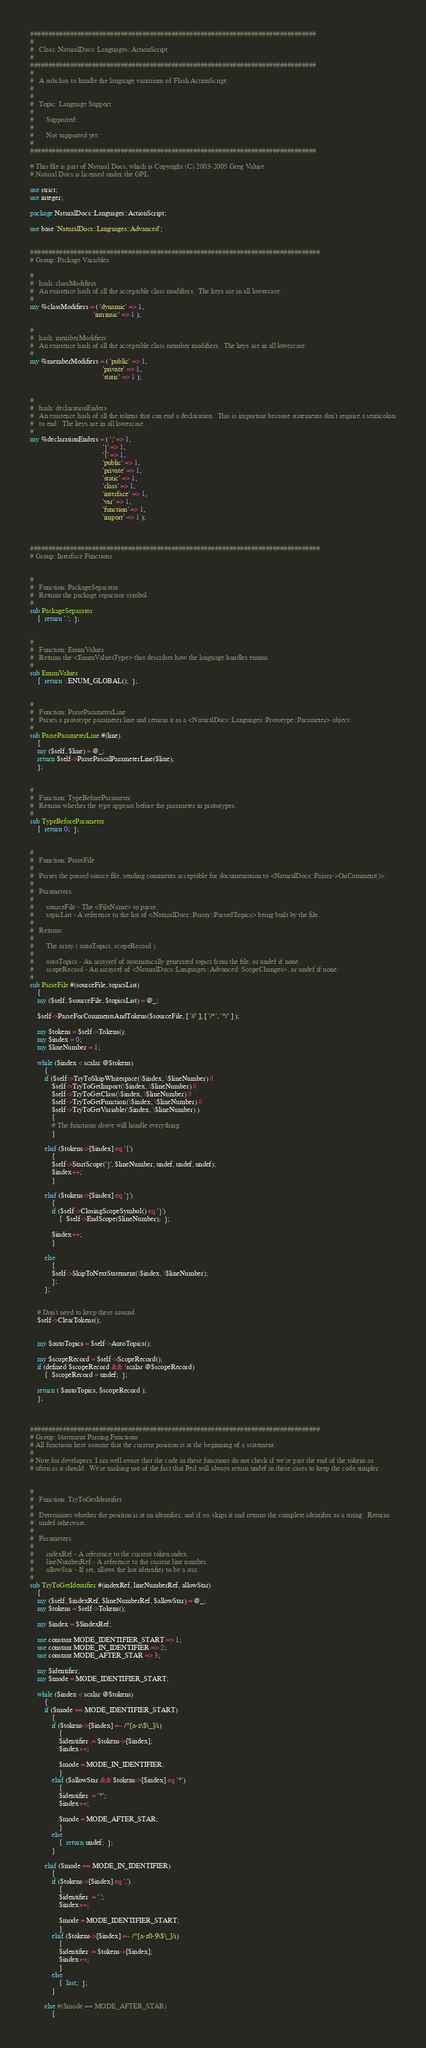<code> <loc_0><loc_0><loc_500><loc_500><_Perl_>###############################################################################
#
#   Class: NaturalDocs::Languages::ActionScript
#
###############################################################################
#
#   A subclass to handle the language variations of Flash ActionScript.
#
#
#   Topic: Language Support
#
#       Supported:
#
#       Not supported yet:
#
###############################################################################

# This file is part of Natural Docs, which is Copyright (C) 2003-2005 Greg Valure
# Natural Docs is licensed under the GPL

use strict;
use integer;

package NaturalDocs::Languages::ActionScript;

use base 'NaturalDocs::Languages::Advanced';


################################################################################
# Group: Package Variables

#
#   hash: classModifiers
#   An existence hash of all the acceptable class modifiers.  The keys are in all lowercase.
#
my %classModifiers = ( 'dynamic' => 1,
                                   'intrinsic' => 1 );

#
#   hash: memberModifiers
#   An existence hash of all the acceptable class member modifiers.  The keys are in all lowercase.
#
my %memberModifiers = ( 'public' => 1,
                                        'private' => 1,
                                        'static' => 1 );


#
#   hash: declarationEnders
#   An existence hash of all the tokens that can end a declaration.  This is important because statements don't require a semicolon
#   to end.  The keys are in all lowercase.
#
my %declarationEnders = ( ';' => 1,
                                        '}' => 1,
                                        '{' => 1,
                                        'public' => 1,
                                        'private' => 1,
                                        'static' => 1,
                                        'class' => 1,
                                        'interface' => 1,
                                        'var' => 1,
                                        'function' => 1,
                                        'import' => 1 );



################################################################################
# Group: Interface Functions


#
#   Function: PackageSeparator
#   Returns the package separator symbol.
#
sub PackageSeparator
    {  return '.';  };


#
#   Function: EnumValues
#   Returns the <EnumValuesType> that describes how the language handles enums.
#
sub EnumValues
    {  return ::ENUM_GLOBAL();  };


#
#   Function: ParseParameterLine
#   Parses a prototype parameter line and returns it as a <NaturalDocs::Languages::Prototype::Parameter> object.
#
sub ParseParameterLine #(line)
    {
    my ($self, $line) = @_;
    return $self->ParsePascalParameterLine($line);
    };


#
#   Function: TypeBeforeParameter
#   Returns whether the type appears before the parameter in prototypes.
#
sub TypeBeforeParameter
    {  return 0;  };


#
#   Function: ParseFile
#
#   Parses the passed source file, sending comments acceptable for documentation to <NaturalDocs::Parser->OnComment()>.
#
#   Parameters:
#
#       sourceFile - The <FileName> to parse.
#       topicList - A reference to the list of <NaturalDocs::Parser::ParsedTopics> being built by the file.
#
#   Returns:
#
#       The array ( autoTopics, scopeRecord ).
#
#       autoTopics - An arrayref of automatically generated topics from the file, or undef if none.
#       scopeRecord - An arrayref of <NaturalDocs::Languages::Advanced::ScopeChanges>, or undef if none.
#
sub ParseFile #(sourceFile, topicsList)
    {
    my ($self, $sourceFile, $topicsList) = @_;

    $self->ParseForCommentsAndTokens($sourceFile, [ '//' ], [ '/*', '*/' ] );

    my $tokens = $self->Tokens();
    my $index = 0;
    my $lineNumber = 1;

    while ($index < scalar @$tokens)
        {
        if ($self->TryToSkipWhitespace(\$index, \$lineNumber) ||
            $self->TryToGetImport(\$index, \$lineNumber) ||
            $self->TryToGetClass(\$index, \$lineNumber) ||
            $self->TryToGetFunction(\$index, \$lineNumber) ||
            $self->TryToGetVariable(\$index, \$lineNumber) )
            {
            # The functions above will handle everything.
            }

        elsif ($tokens->[$index] eq '{')
            {
            $self->StartScope('}', $lineNumber, undef, undef, undef);
            $index++;
            }

        elsif ($tokens->[$index] eq '}')
            {
            if ($self->ClosingScopeSymbol() eq '}')
                {  $self->EndScope($lineNumber);  };

            $index++;
            }

        else
            {
            $self->SkipToNextStatement(\$index, \$lineNumber);
            };
        };


    # Don't need to keep these around.
    $self->ClearTokens();


    my $autoTopics = $self->AutoTopics();

    my $scopeRecord = $self->ScopeRecord();
    if (defined $scopeRecord && !scalar @$scopeRecord)
        {  $scopeRecord = undef;  };

    return ( $autoTopics, $scopeRecord );
    };



################################################################################
# Group: Statement Parsing Functions
# All functions here assume that the current position is at the beginning of a statement.
#
# Note for developers: I am well aware that the code in these functions do not check if we're past the end of the tokens as
# often as it should.  We're making use of the fact that Perl will always return undef in these cases to keep the code simpler.


#
#   Function: TryToGetIdentifier
#
#   Determines whether the position is at an identifier, and if so, skips it and returns the complete identifier as a string.  Returns
#   undef otherwise.
#
#   Parameters:
#
#       indexRef - A reference to the current token index.
#       lineNumberRef - A reference to the current line number.
#       allowStar - If set, allows the last identifier to be a star.
#
sub TryToGetIdentifier #(indexRef, lineNumberRef, allowStar)
    {
    my ($self, $indexRef, $lineNumberRef, $allowStar) = @_;
    my $tokens = $self->Tokens();

    my $index = $$indexRef;

    use constant MODE_IDENTIFIER_START => 1;
    use constant MODE_IN_IDENTIFIER => 2;
    use constant MODE_AFTER_STAR => 3;

    my $identifier;
    my $mode = MODE_IDENTIFIER_START;

    while ($index < scalar @$tokens)
        {
        if ($mode == MODE_IDENTIFIER_START)
            {
            if ($tokens->[$index] =~ /^[a-z\$\_]/i)
                {
                $identifier .= $tokens->[$index];
                $index++;

                $mode = MODE_IN_IDENTIFIER;
                }
            elsif ($allowStar && $tokens->[$index] eq '*')
                {
                $identifier .= '*';
                $index++;

                $mode = MODE_AFTER_STAR;
                }
            else
                {  return undef;  };
            }

        elsif ($mode == MODE_IN_IDENTIFIER)
            {
            if ($tokens->[$index] eq '.')
                {
                $identifier .= '.';
                $index++;

                $mode = MODE_IDENTIFIER_START;
                }
            elsif ($tokens->[$index] =~ /^[a-z0-9\$\_]/i)
                {
                $identifier .= $tokens->[$index];
                $index++;
                }
            else
                {  last;  };
            }

        else #($mode == MODE_AFTER_STAR)
            {</code> 